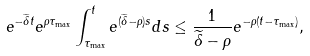Convert formula to latex. <formula><loc_0><loc_0><loc_500><loc_500>e ^ { - \widetilde { \delta } t } e ^ { \rho \tau _ { \max } } \int _ { \tau _ { \max } } ^ { t } e ^ { ( \widetilde { \delta } - \rho ) s } d s \leq \frac { 1 } { \widetilde { \delta } - \rho } e ^ { - \rho ( t - \tau _ { \max } ) } ,</formula> 